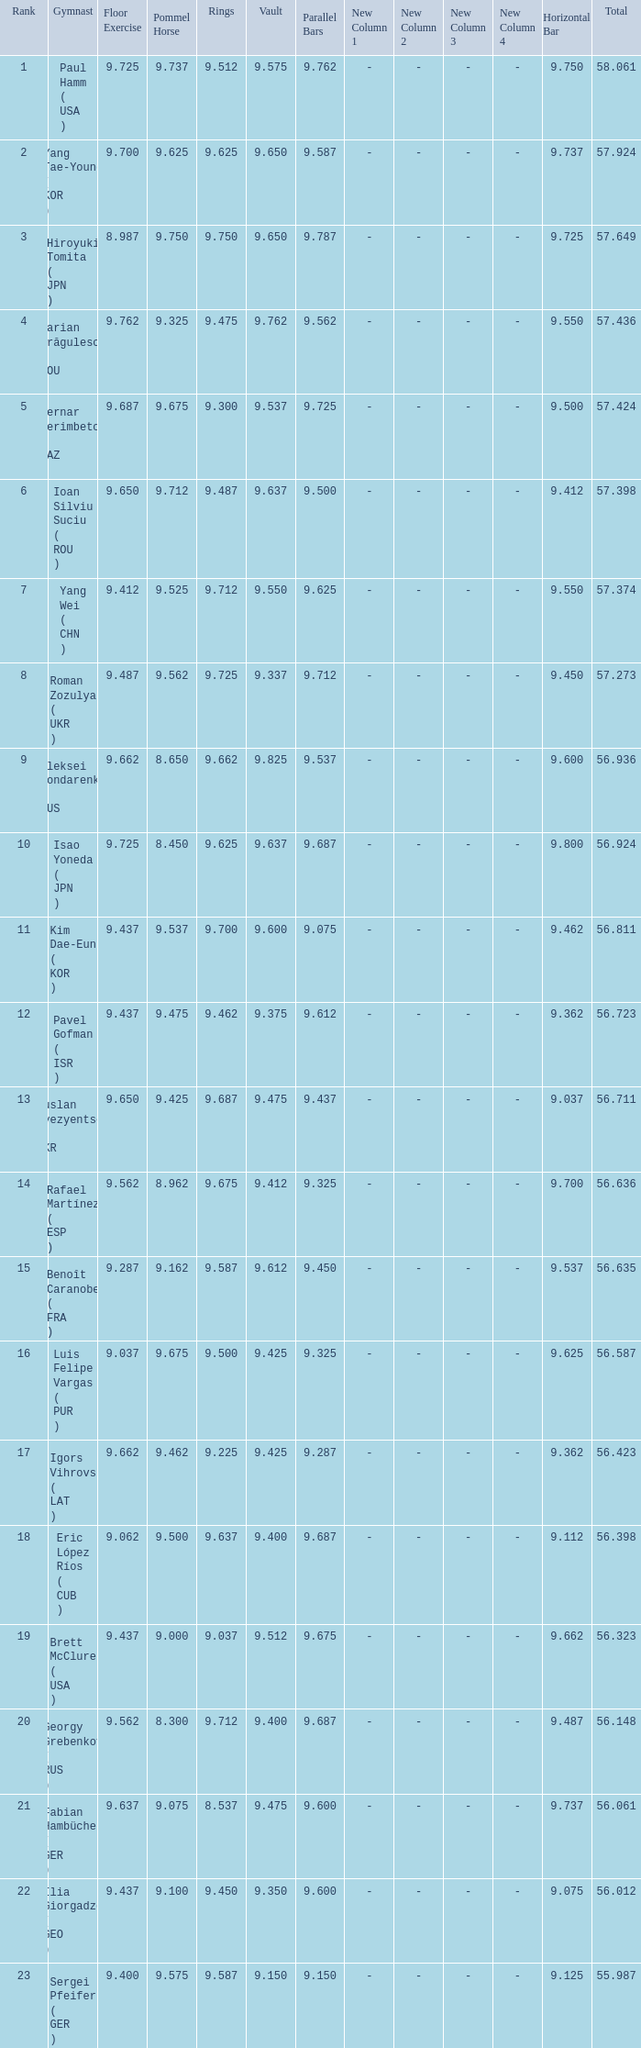What is the vault score for the total of 56.635? 9.612. 